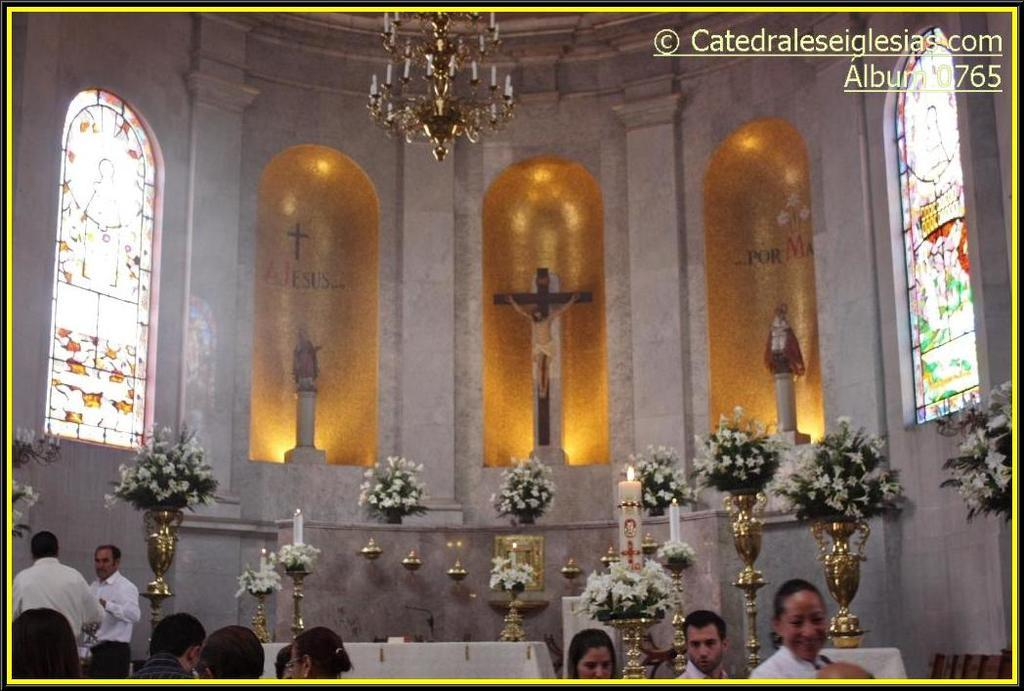What type of building is depicted in the image? The image is an inside view of a church. What decorative elements can be seen in the image? There are flower vases, candles, statues, and a chandelier in the image. What architectural features are present in the image? There are windows in the image. Are there any people visible in the image? Yes, people are visible at the bottom of the image. What type of structure is the swing attached to in the image? There is no swing present in the image; it is an inside view of a church with various decorative and architectural elements. Can you recite the verse written on the wall in the image? There is no verse written on the wall in the image; it is a church with decorative elements and people. 